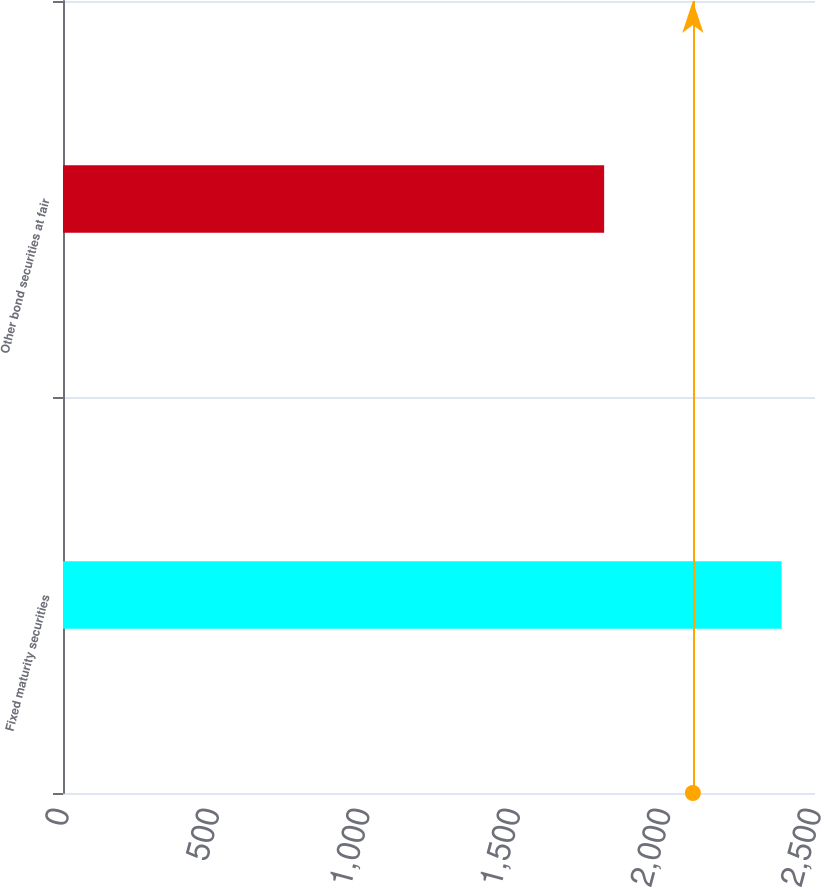<chart> <loc_0><loc_0><loc_500><loc_500><bar_chart><fcel>Fixed maturity securities<fcel>Other bond securities at fair<nl><fcel>2389<fcel>1799<nl></chart> 